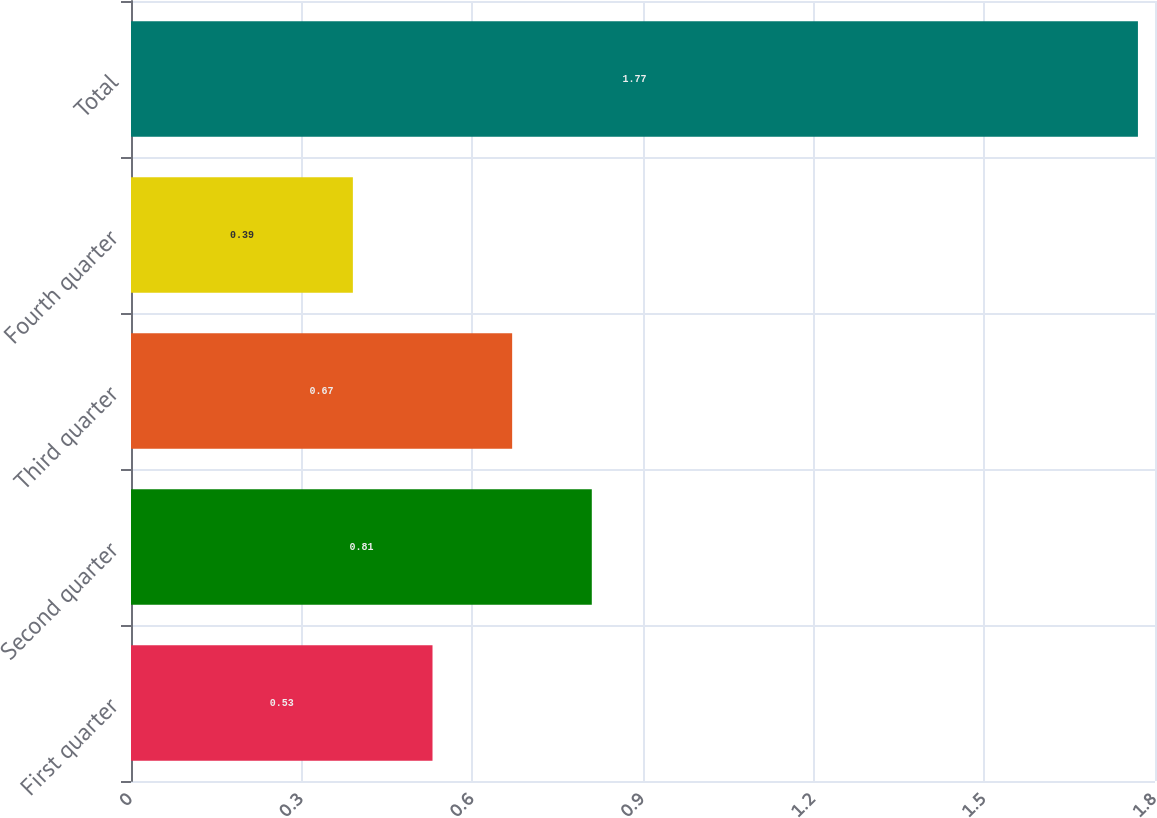Convert chart to OTSL. <chart><loc_0><loc_0><loc_500><loc_500><bar_chart><fcel>First quarter<fcel>Second quarter<fcel>Third quarter<fcel>Fourth quarter<fcel>Total<nl><fcel>0.53<fcel>0.81<fcel>0.67<fcel>0.39<fcel>1.77<nl></chart> 